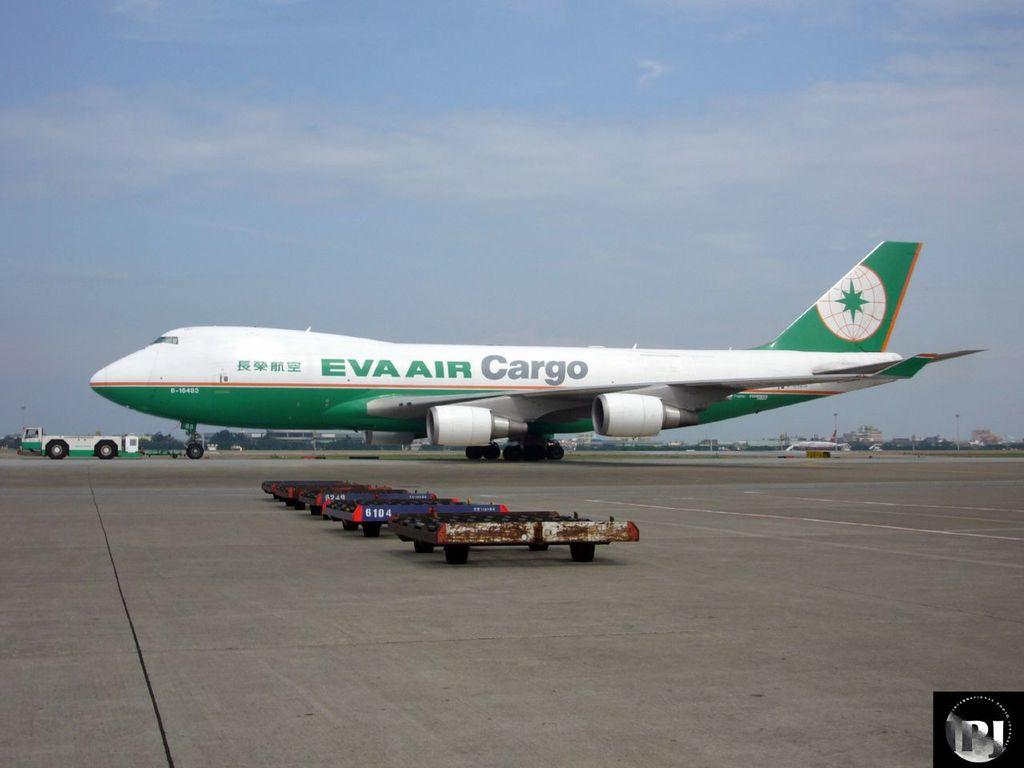<image>
Share a concise interpretation of the image provided. A green and white airplane has EVA AIR Cargo painted on the side. 